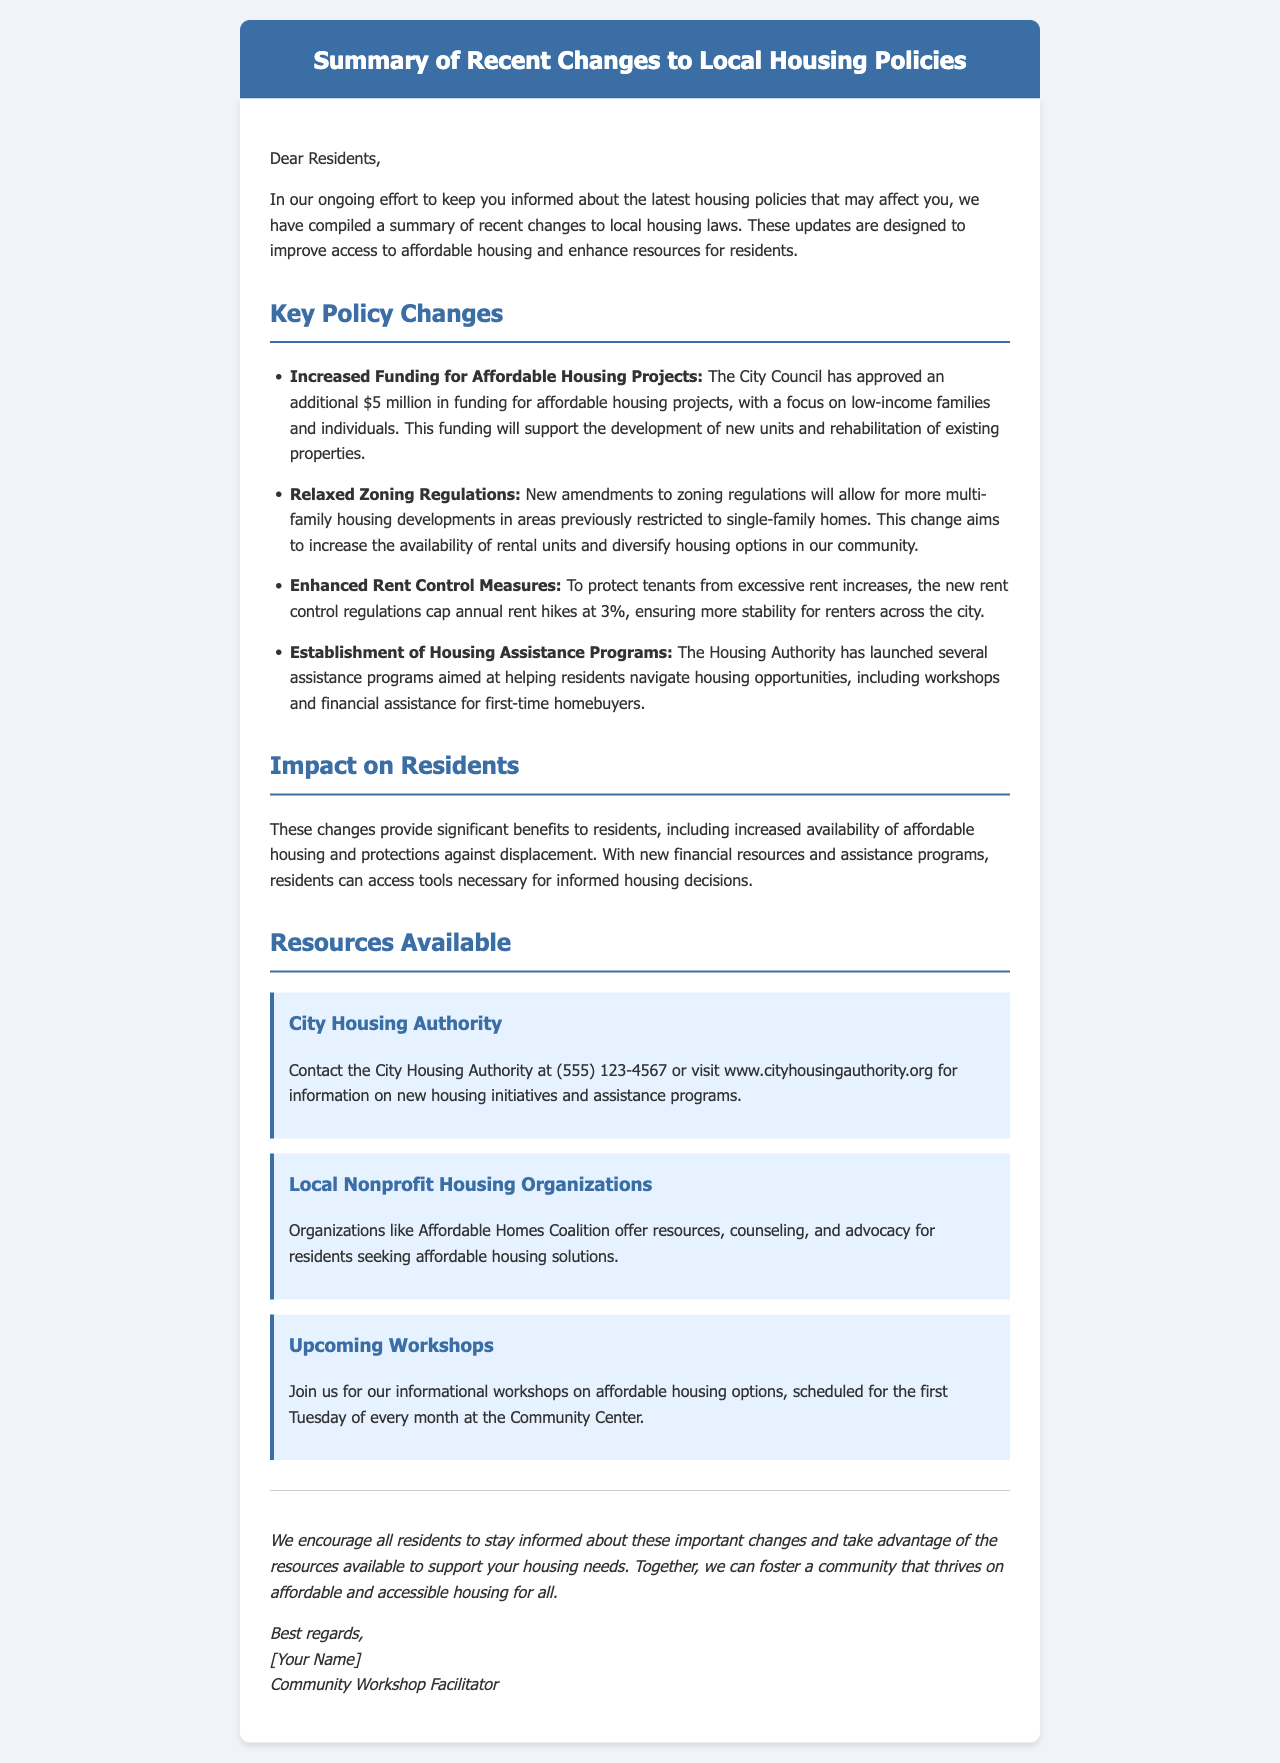What is the additional funding amount approved for affordable housing projects? The additional funding for affordable housing projects is specified as $5 million, as mentioned in the key policy changes.
Answer: $5 million What is the new annual rent hike cap? The document states that the new rent control regulations cap annual rent hikes at 3%.
Answer: 3% What organization offers resources for affordable housing solutions? The document mentions the Affordable Homes Coalition as a local nonprofit housing organization providing resources and advocacy.
Answer: Affordable Homes Coalition When do the upcoming workshops on affordable housing options take place? The document specifies that workshops are scheduled for the first Tuesday of every month at the Community Center.
Answer: First Tuesday of every month What is the main focus of the increased affordable housing funding? The funding focuses on low-income families and individuals, according to the key policy changes section.
Answer: Low-income families and individuals What is one significant benefit for residents mentioned in the impact section? The impact section emphasizes increased availability of affordable housing as a significant benefit for residents.
Answer: Increased availability of affordable housing What is the contact number for the City Housing Authority? The document provides the contact number for the City Housing Authority as (555) 123-4567.
Answer: (555) 123-4567 What is the purpose of the Housing Authority's new assistance programs? The purpose of these programs is aimed at helping residents navigate housing opportunities, particularly for first-time homebuyers.
Answer: Helping residents navigate housing opportunities 